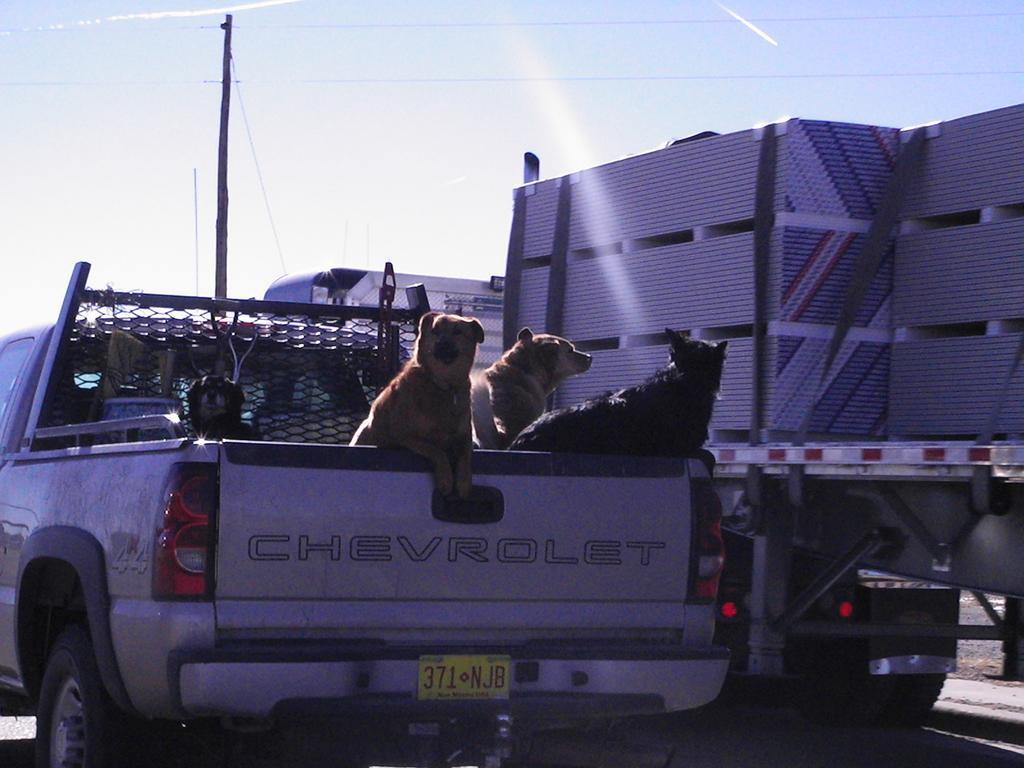Please provide a concise description of this image. In this picture I can see dogs in the car. I can see vehicle on the right hand side. I can see electric pole at the top left hand corner. I can see clear sky. 